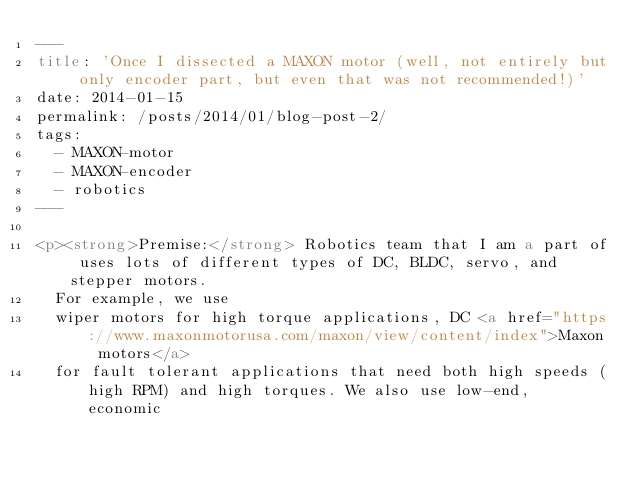<code> <loc_0><loc_0><loc_500><loc_500><_HTML_>---
title: 'Once I dissected a MAXON motor (well, not entirely but only encoder part, but even that was not recommended!)'
date: 2014-01-15
permalink: /posts/2014/01/blog-post-2/
tags:
  - MAXON-motor
  - MAXON-encoder
  - robotics
---

<p><strong>Premise:</strong> Robotics team that I am a part of uses lots of different types of DC, BLDC, servo, and stepper motors.
  For example, we use
  wiper motors for high torque applications, DC <a href="https://www.maxonmotorusa.com/maxon/view/content/index">Maxon motors</a>
  for fault tolerant applications that need both high speeds (high RPM) and high torques. We also use low-end, economic</code> 